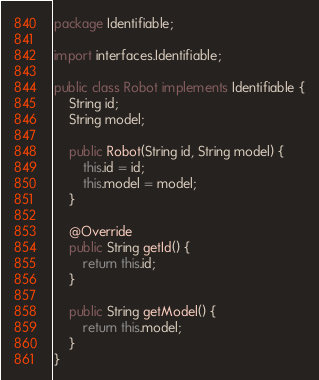Convert code to text. <code><loc_0><loc_0><loc_500><loc_500><_Java_>package Identifiable;

import interfaces.Identifiable;

public class Robot implements Identifiable {
    String id;
    String model;

    public Robot(String id, String model) {
        this.id = id;
        this.model = model;
    }

    @Override
    public String getId() {
        return this.id;
    }

    public String getModel() {
        return this.model;
    }
}
</code> 